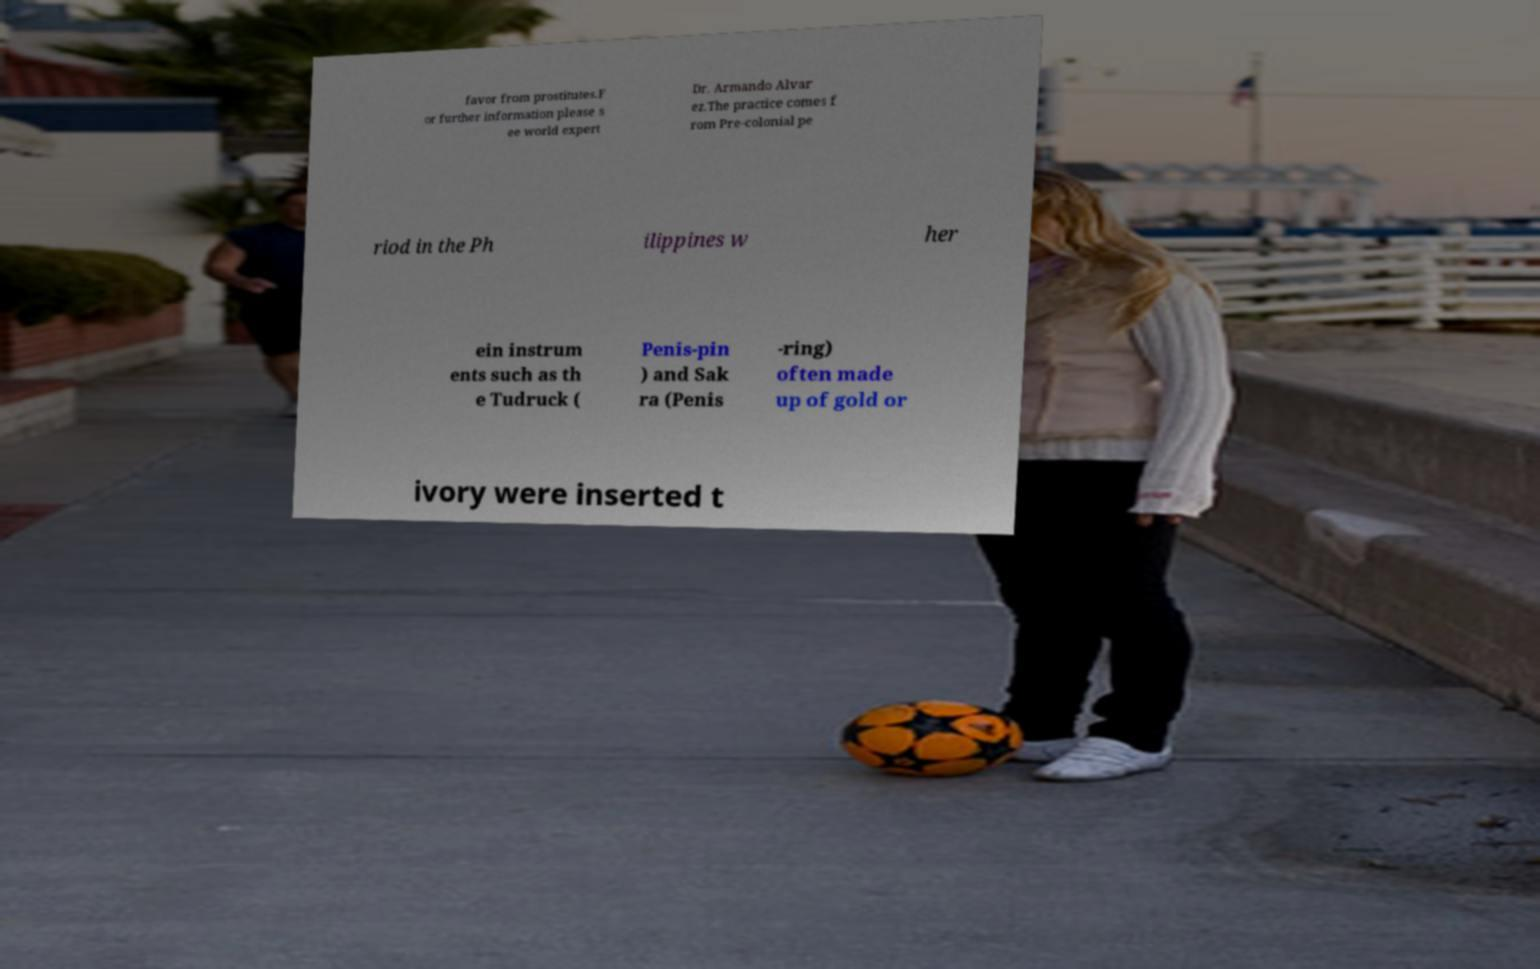I need the written content from this picture converted into text. Can you do that? favor from prostitutes.F or further information please s ee world expert Dr. Armando Alvar ez.The practice comes f rom Pre-colonial pe riod in the Ph ilippines w her ein instrum ents such as th e Tudruck ( Penis-pin ) and Sak ra (Penis -ring) often made up of gold or ivory were inserted t 